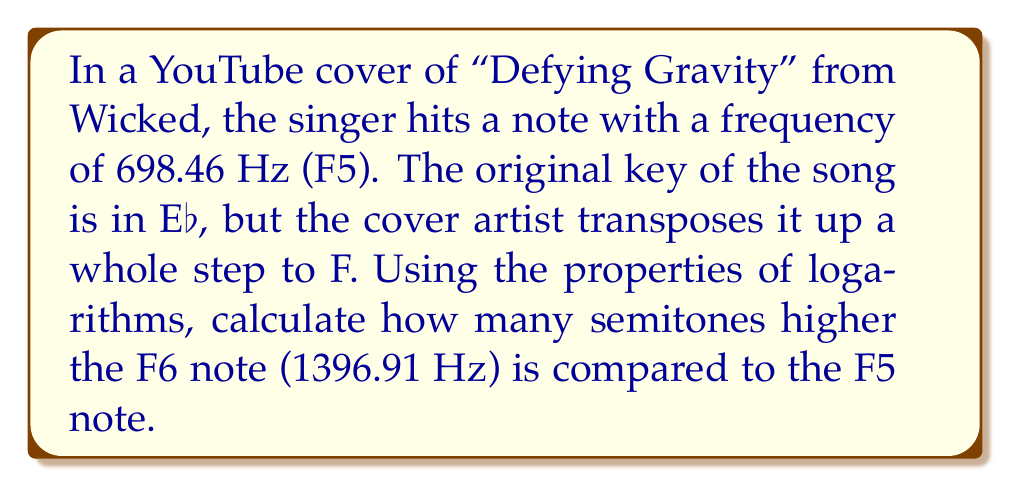Solve this math problem. Let's approach this step-by-step:

1) The relationship between frequency and number of semitones is logarithmic. We can use the formula:

   $n = 12 \log_2(\frac{f_2}{f_1})$

   Where $n$ is the number of semitones, $f_2$ is the higher frequency, and $f_1$ is the lower frequency.

2) We're given:
   $f_1 = 698.46$ Hz (F5)
   $f_2 = 1396.91$ Hz (F6)

3) Let's substitute these into our formula:

   $n = 12 \log_2(\frac{1396.91}{698.46})$

4) Simplify inside the parentheses:

   $n = 12 \log_2(2)$

5) The logarithm of a number to its own base is 1:

   $n = 12 \cdot 1 = 12$

Therefore, F6 is 12 semitones higher than F5.

This makes sense musically, as there are 12 semitones in an octave, and F6 is exactly one octave higher than F5.
Answer: 12 semitones 